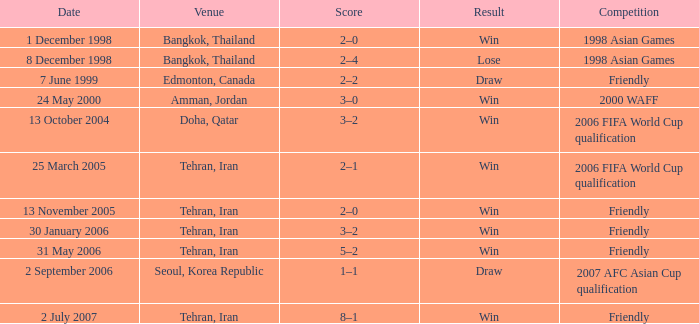What was the competition on 7 June 1999? Friendly. 